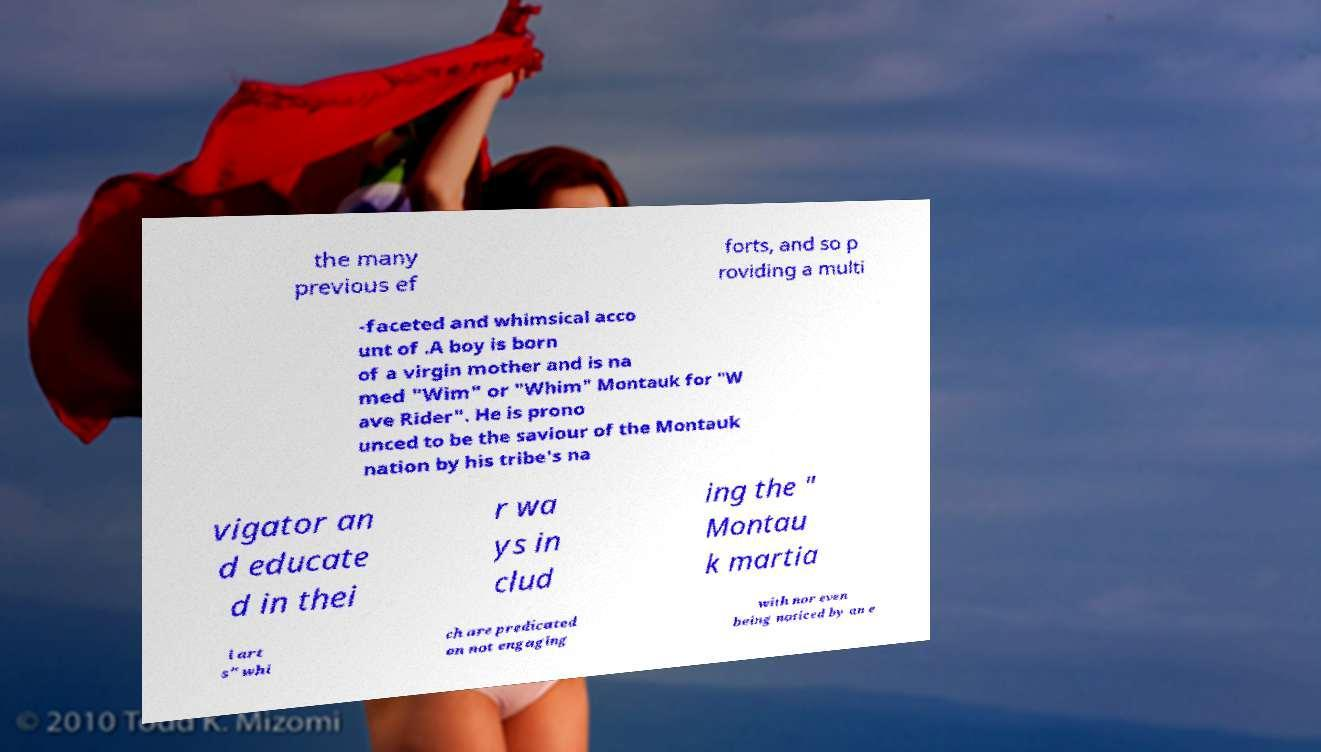Please identify and transcribe the text found in this image. the many previous ef forts, and so p roviding a multi -faceted and whimsical acco unt of .A boy is born of a virgin mother and is na med "Wim" or "Whim" Montauk for "W ave Rider". He is prono unced to be the saviour of the Montauk nation by his tribe's na vigator an d educate d in thei r wa ys in clud ing the " Montau k martia l art s" whi ch are predicated on not engaging with nor even being noticed by an e 